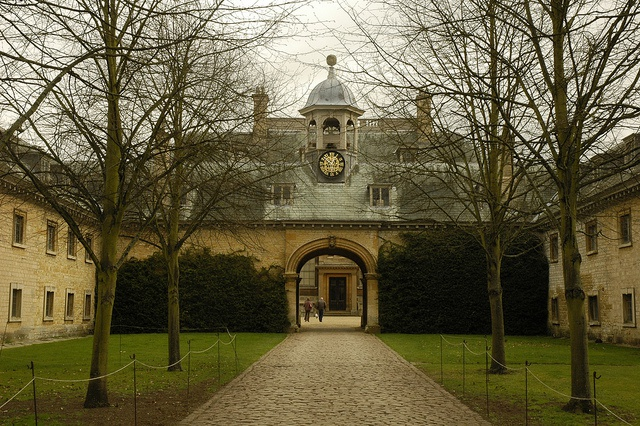Describe the objects in this image and their specific colors. I can see clock in gray, black, and olive tones, people in gray, olive, maroon, black, and tan tones, and people in gray and black tones in this image. 